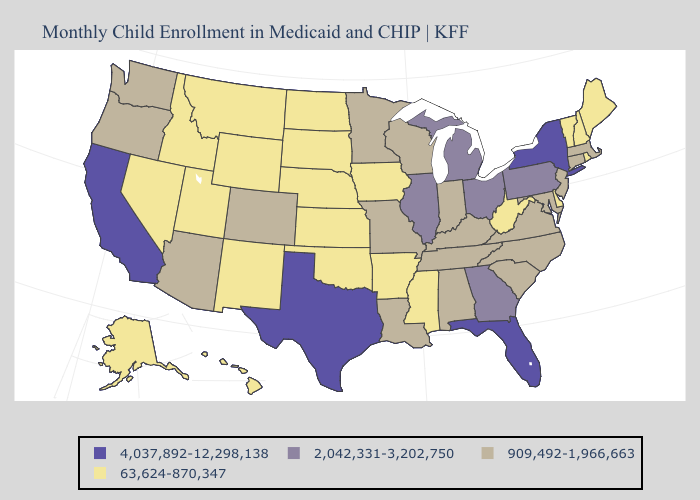Name the states that have a value in the range 63,624-870,347?
Quick response, please. Alaska, Arkansas, Delaware, Hawaii, Idaho, Iowa, Kansas, Maine, Mississippi, Montana, Nebraska, Nevada, New Hampshire, New Mexico, North Dakota, Oklahoma, Rhode Island, South Dakota, Utah, Vermont, West Virginia, Wyoming. What is the value of Arizona?
Concise answer only. 909,492-1,966,663. Name the states that have a value in the range 2,042,331-3,202,750?
Keep it brief. Georgia, Illinois, Michigan, Ohio, Pennsylvania. Name the states that have a value in the range 4,037,892-12,298,138?
Give a very brief answer. California, Florida, New York, Texas. Does Kansas have the highest value in the USA?
Concise answer only. No. What is the lowest value in states that border Tennessee?
Keep it brief. 63,624-870,347. Name the states that have a value in the range 909,492-1,966,663?
Answer briefly. Alabama, Arizona, Colorado, Connecticut, Indiana, Kentucky, Louisiana, Maryland, Massachusetts, Minnesota, Missouri, New Jersey, North Carolina, Oregon, South Carolina, Tennessee, Virginia, Washington, Wisconsin. Name the states that have a value in the range 4,037,892-12,298,138?
Quick response, please. California, Florida, New York, Texas. Name the states that have a value in the range 909,492-1,966,663?
Keep it brief. Alabama, Arizona, Colorado, Connecticut, Indiana, Kentucky, Louisiana, Maryland, Massachusetts, Minnesota, Missouri, New Jersey, North Carolina, Oregon, South Carolina, Tennessee, Virginia, Washington, Wisconsin. What is the value of New York?
Concise answer only. 4,037,892-12,298,138. What is the lowest value in states that border Maine?
Answer briefly. 63,624-870,347. Name the states that have a value in the range 63,624-870,347?
Answer briefly. Alaska, Arkansas, Delaware, Hawaii, Idaho, Iowa, Kansas, Maine, Mississippi, Montana, Nebraska, Nevada, New Hampshire, New Mexico, North Dakota, Oklahoma, Rhode Island, South Dakota, Utah, Vermont, West Virginia, Wyoming. Does the map have missing data?
Concise answer only. No. What is the value of New Hampshire?
Keep it brief. 63,624-870,347. What is the value of Ohio?
Keep it brief. 2,042,331-3,202,750. 